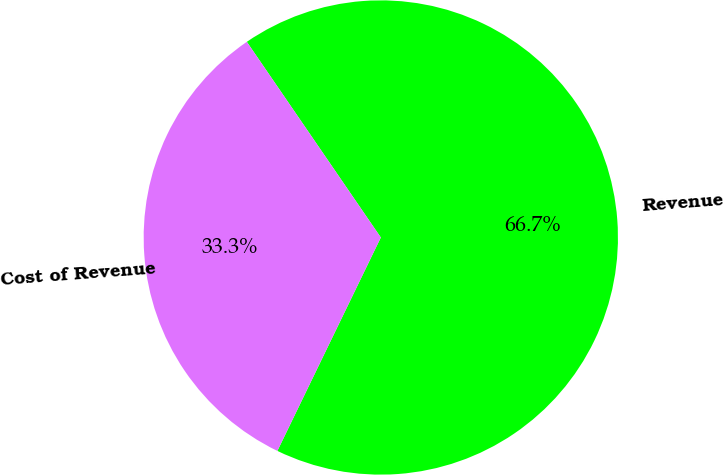Convert chart. <chart><loc_0><loc_0><loc_500><loc_500><pie_chart><fcel>Revenue<fcel>Cost of Revenue<nl><fcel>66.74%<fcel>33.26%<nl></chart> 